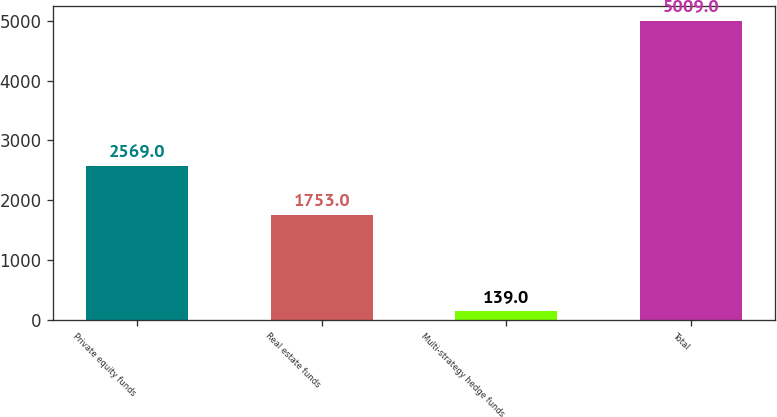Convert chart. <chart><loc_0><loc_0><loc_500><loc_500><bar_chart><fcel>Private equity funds<fcel>Real estate funds<fcel>Multi-strategy hedge funds<fcel>Total<nl><fcel>2569<fcel>1753<fcel>139<fcel>5009<nl></chart> 